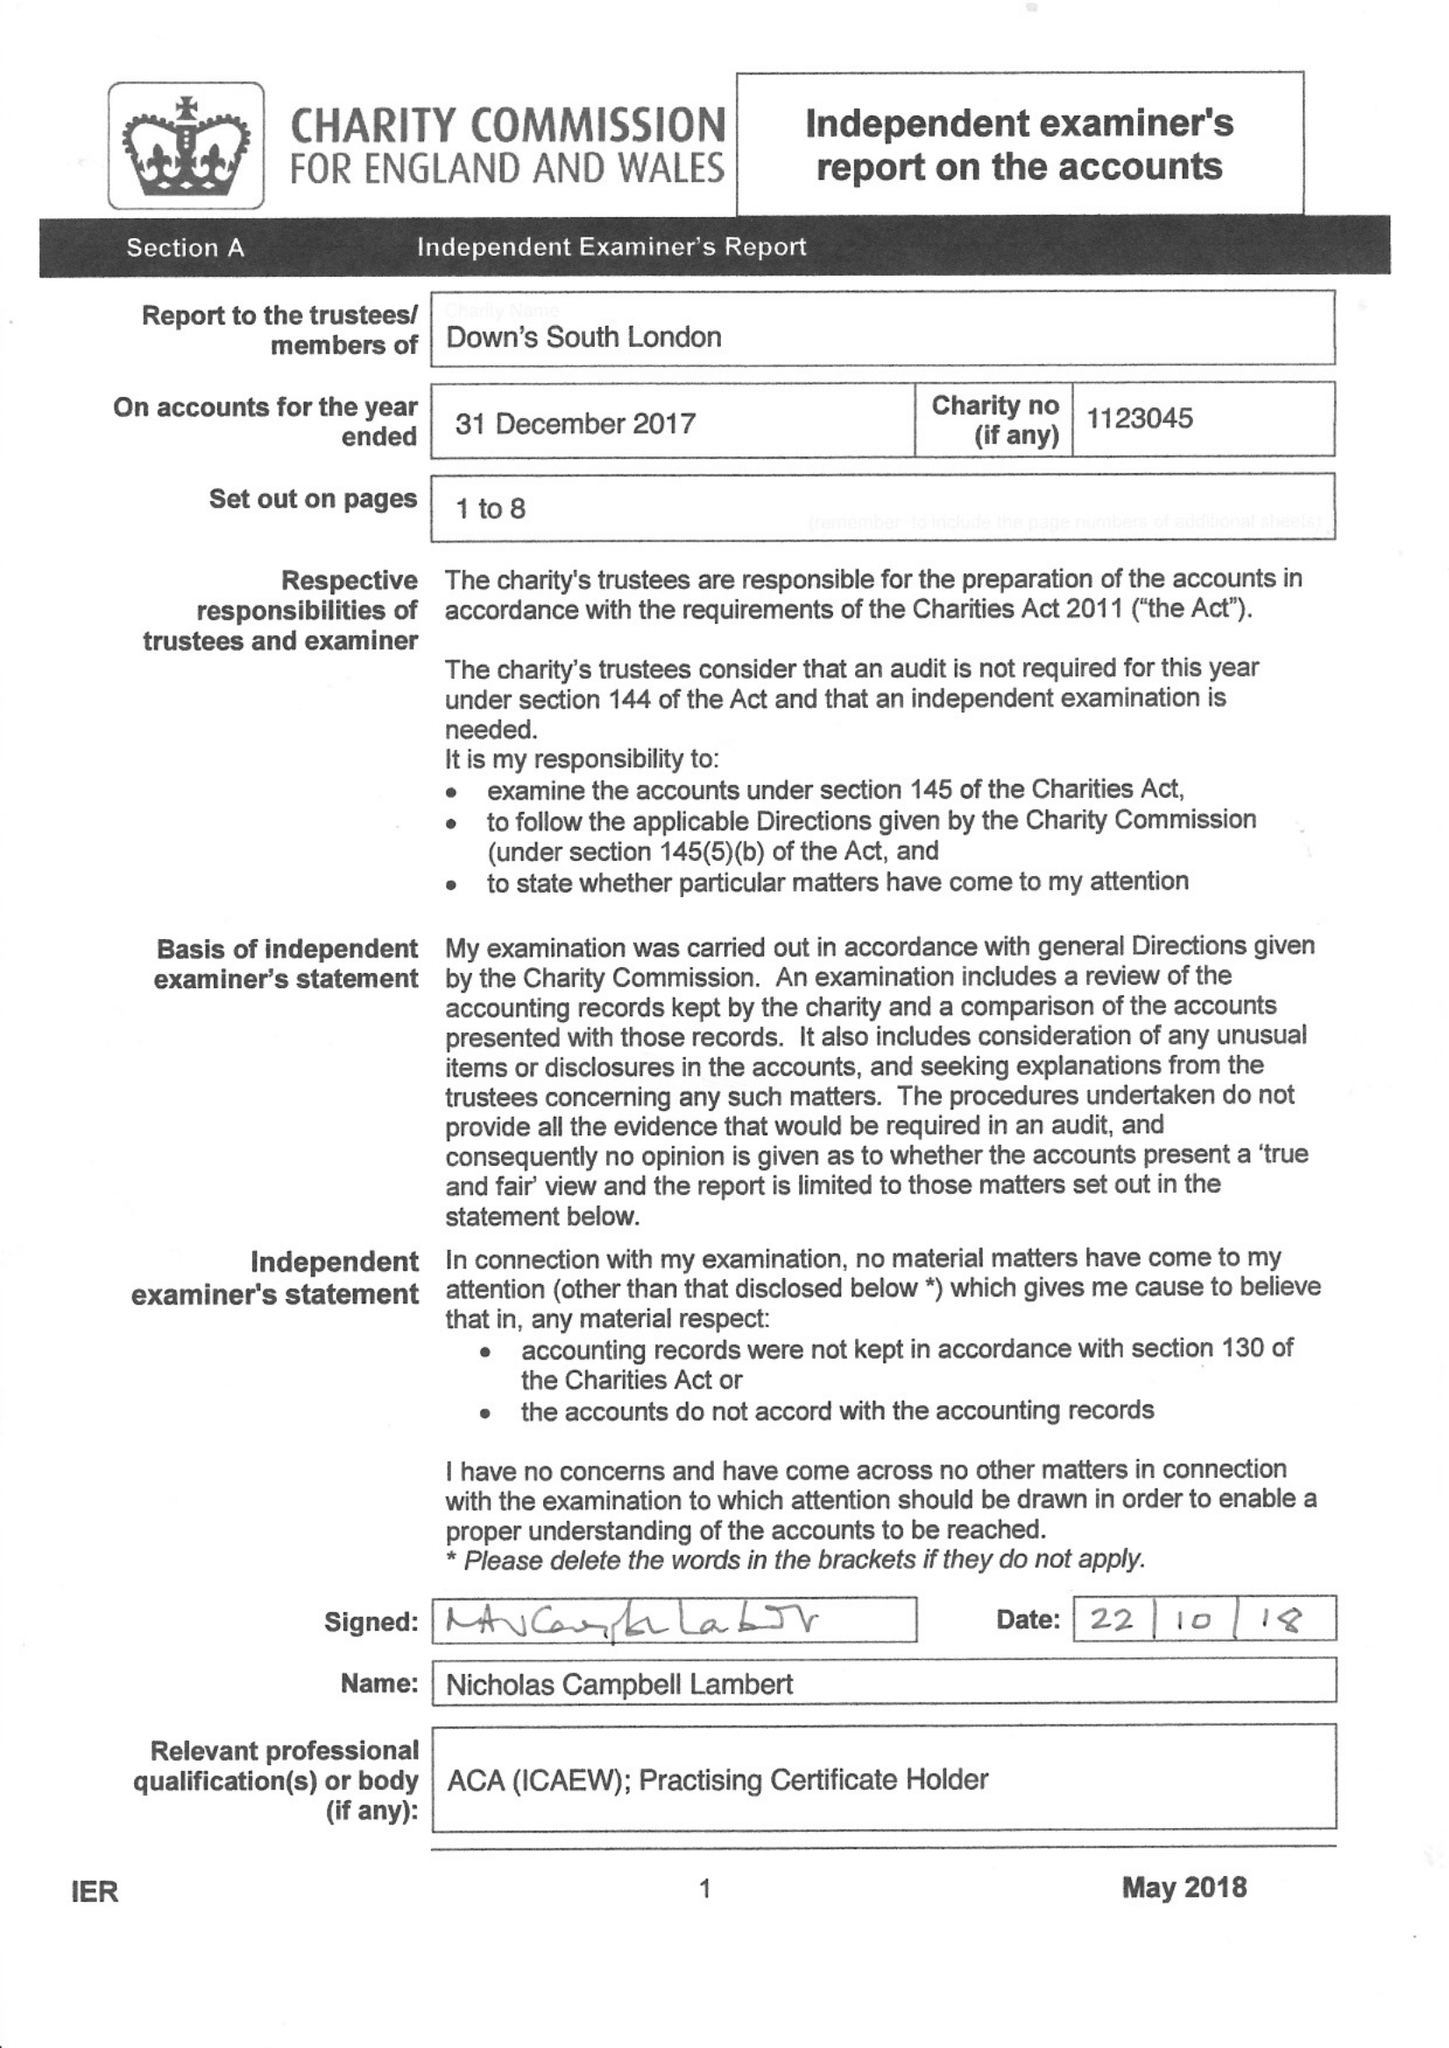What is the value for the address__street_line?
Answer the question using a single word or phrase. 59 LYNDHURST GROVE 